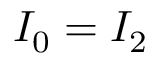Convert formula to latex. <formula><loc_0><loc_0><loc_500><loc_500>I _ { 0 } = I _ { 2 }</formula> 